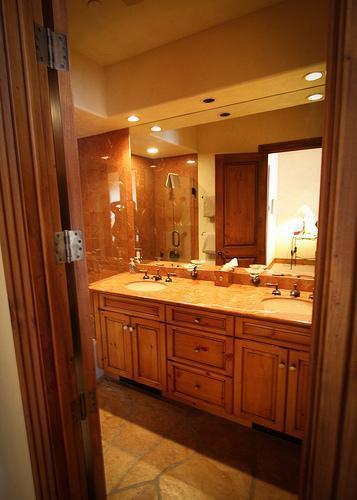How many sinks are visible?
Give a very brief answer. 2. How many cabinet doors are visible?
Give a very brief answer. 7. 